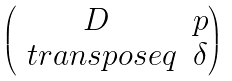Convert formula to latex. <formula><loc_0><loc_0><loc_500><loc_500>\begin{pmatrix} D & p \\ \ t r a n s p o s e { q } & \delta \end{pmatrix}</formula> 